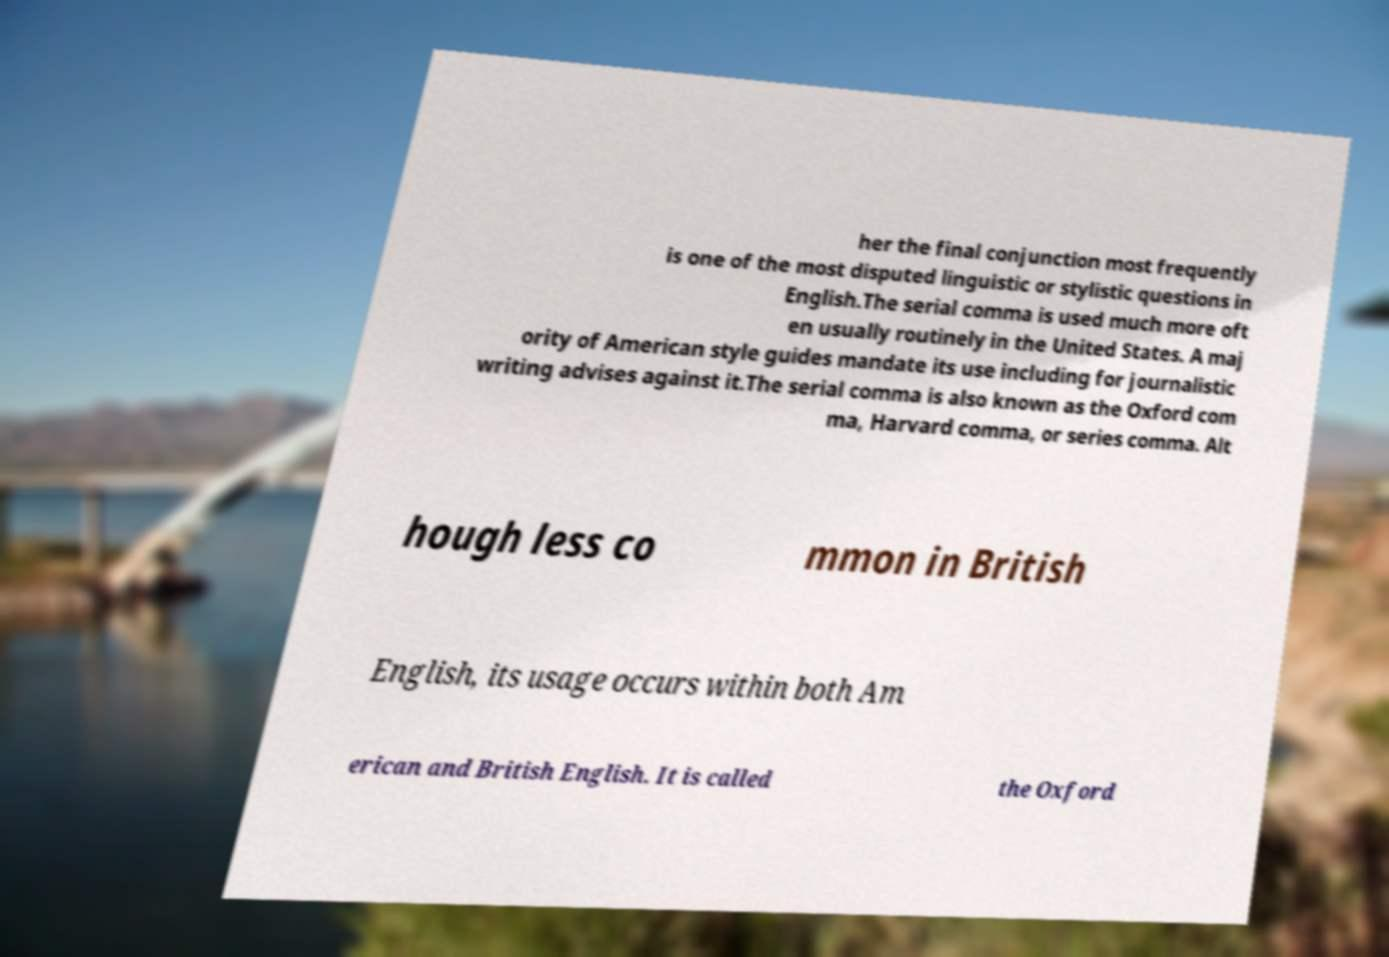Please read and relay the text visible in this image. What does it say? her the final conjunction most frequently is one of the most disputed linguistic or stylistic questions in English.The serial comma is used much more oft en usually routinely in the United States. A maj ority of American style guides mandate its use including for journalistic writing advises against it.The serial comma is also known as the Oxford com ma, Harvard comma, or series comma. Alt hough less co mmon in British English, its usage occurs within both Am erican and British English. It is called the Oxford 